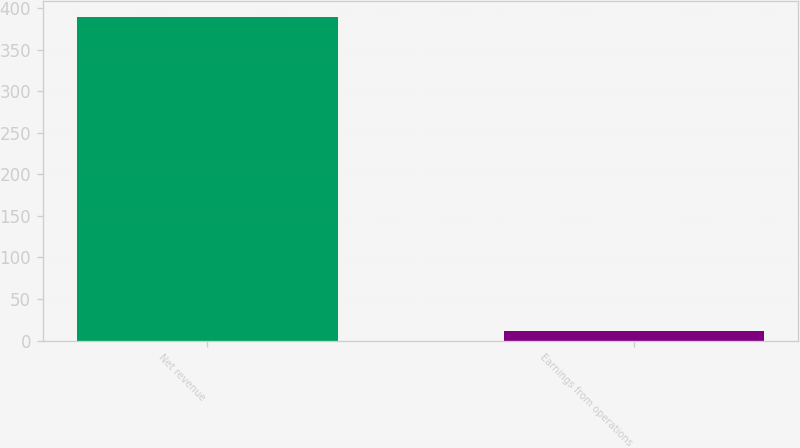<chart> <loc_0><loc_0><loc_500><loc_500><bar_chart><fcel>Net revenue<fcel>Earnings from operations<nl><fcel>389<fcel>11.1<nl></chart> 